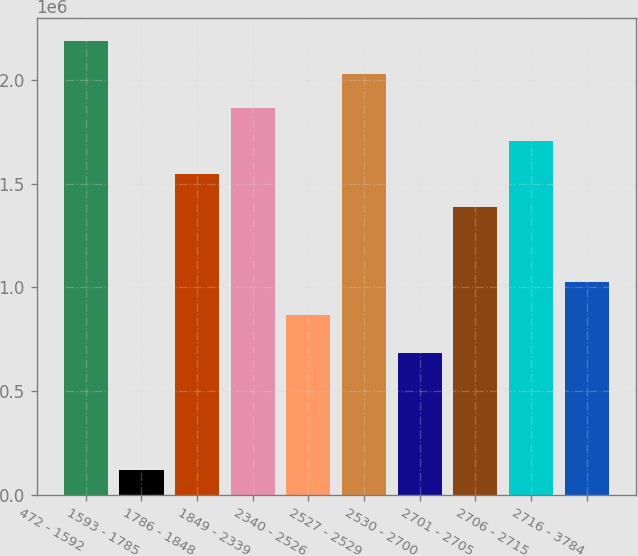Convert chart. <chart><loc_0><loc_0><loc_500><loc_500><bar_chart><fcel>472 - 1592<fcel>1593 - 1785<fcel>1786 - 1848<fcel>1849 - 2339<fcel>2340 - 2526<fcel>2527 - 2529<fcel>2530 - 2700<fcel>2701 - 2705<fcel>2706 - 2715<fcel>2716 - 3784<nl><fcel>2.18864e+06<fcel>120537<fcel>1.54749e+06<fcel>1.86807e+06<fcel>868014<fcel>2.02835e+06<fcel>683275<fcel>1.38721e+06<fcel>1.70778e+06<fcel>1.0283e+06<nl></chart> 